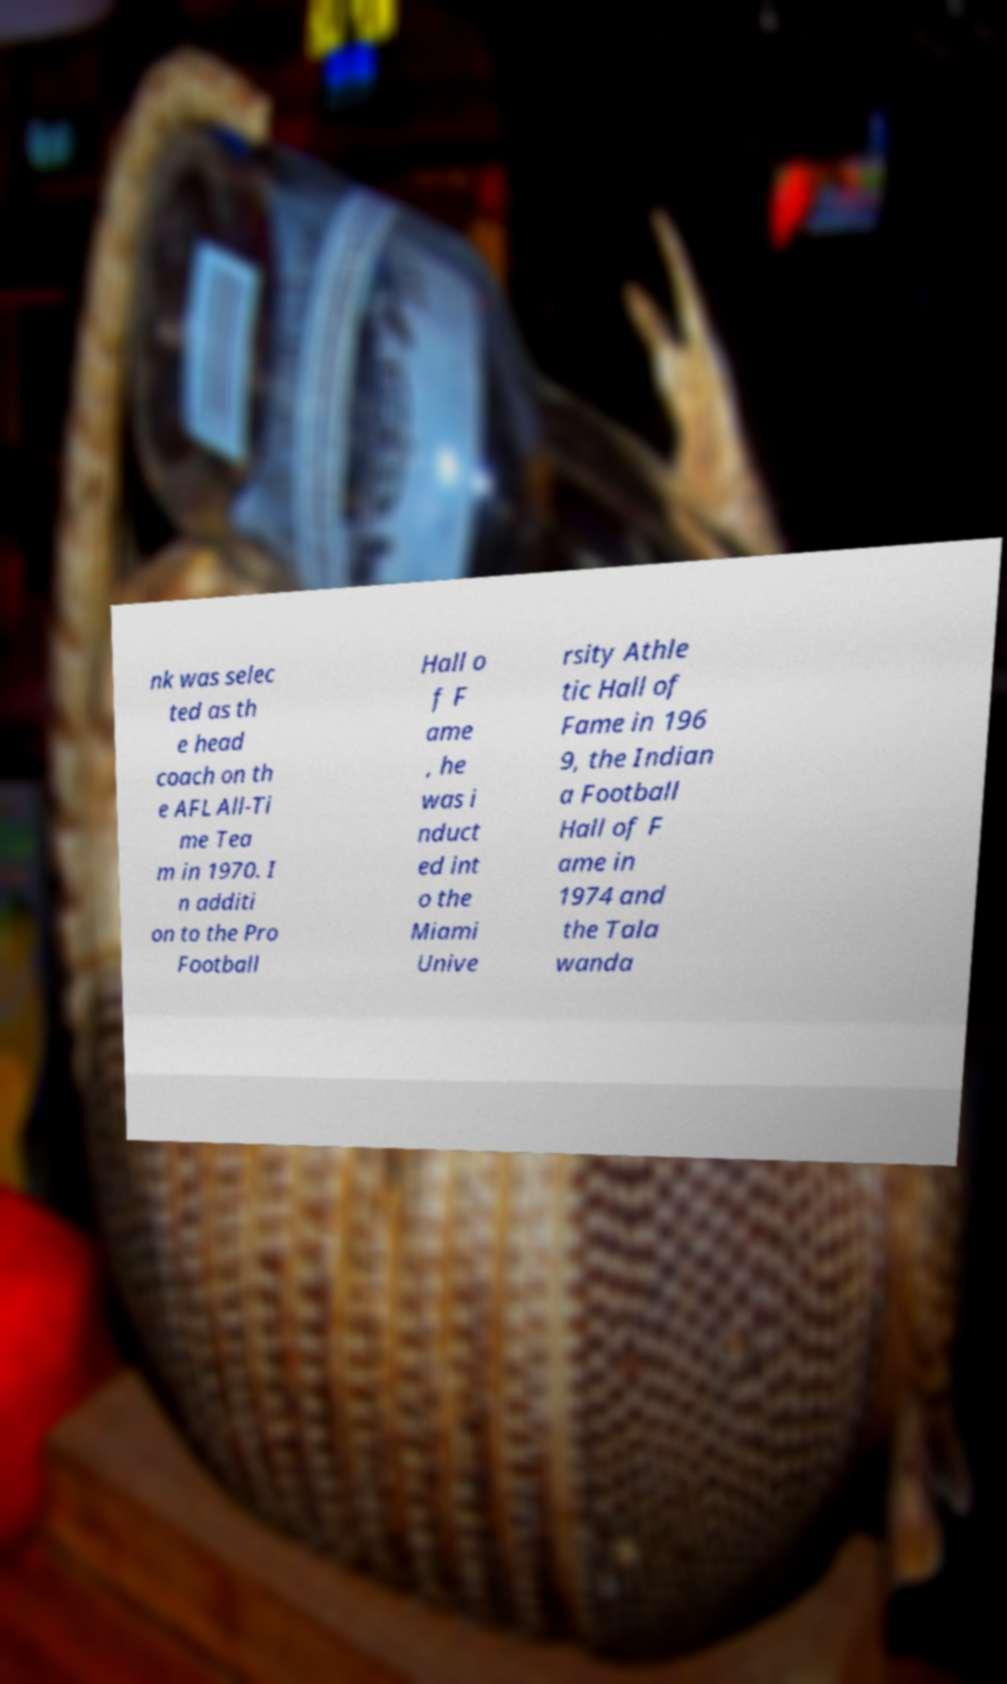Please identify and transcribe the text found in this image. nk was selec ted as th e head coach on th e AFL All-Ti me Tea m in 1970. I n additi on to the Pro Football Hall o f F ame , he was i nduct ed int o the Miami Unive rsity Athle tic Hall of Fame in 196 9, the Indian a Football Hall of F ame in 1974 and the Tala wanda 